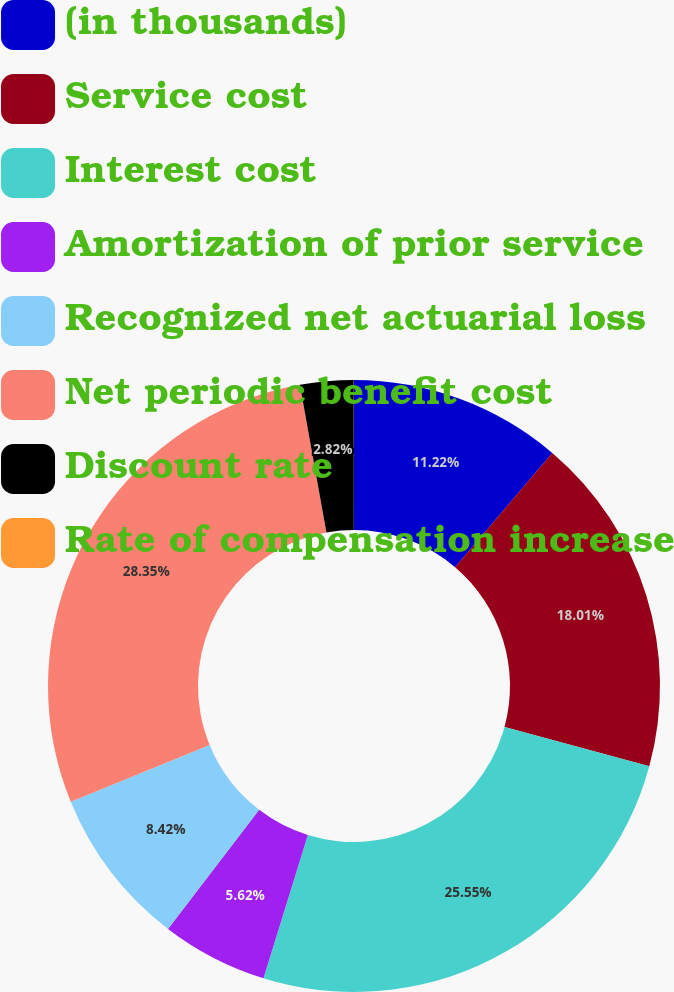<chart> <loc_0><loc_0><loc_500><loc_500><pie_chart><fcel>(in thousands)<fcel>Service cost<fcel>Interest cost<fcel>Amortization of prior service<fcel>Recognized net actuarial loss<fcel>Net periodic benefit cost<fcel>Discount rate<fcel>Rate of compensation increase<nl><fcel>11.22%<fcel>18.01%<fcel>25.55%<fcel>5.62%<fcel>8.42%<fcel>28.35%<fcel>2.82%<fcel>0.01%<nl></chart> 